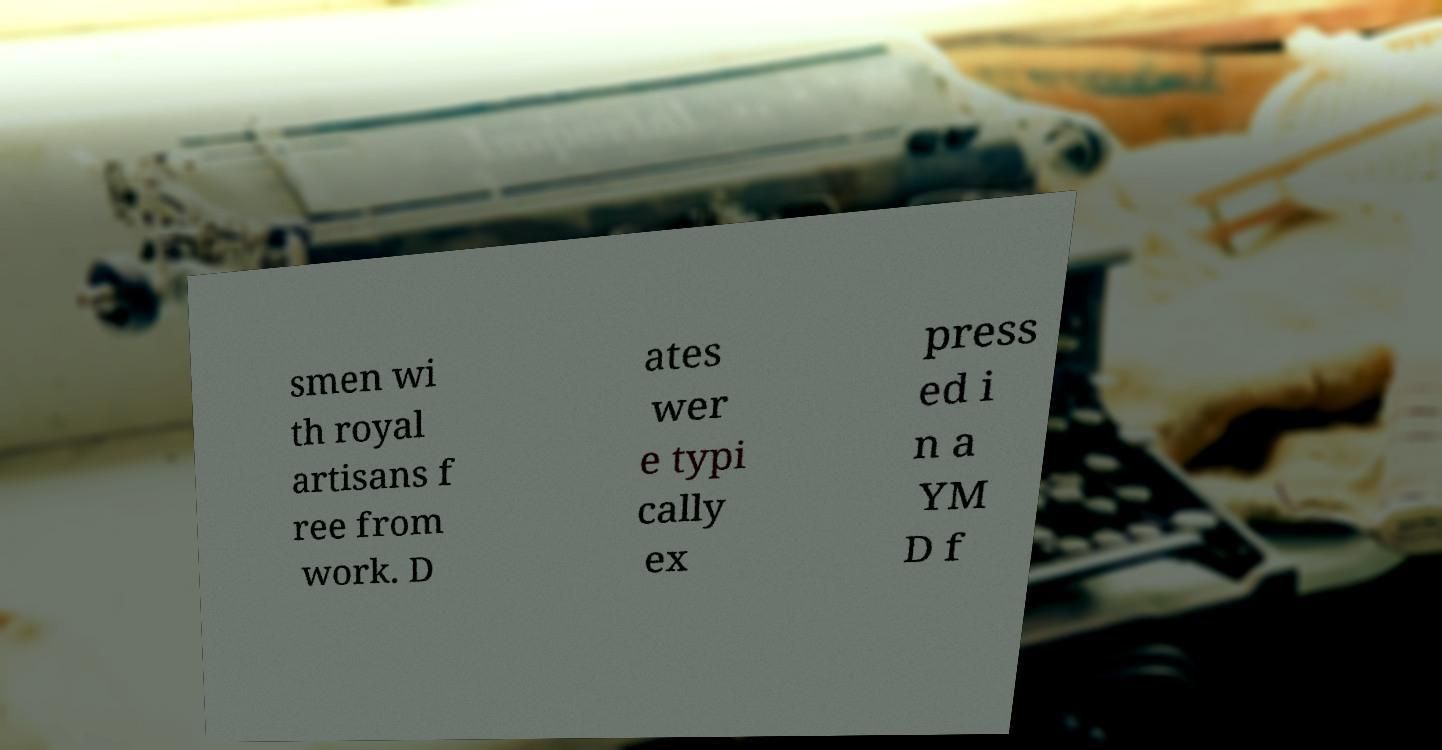Can you read and provide the text displayed in the image?This photo seems to have some interesting text. Can you extract and type it out for me? smen wi th royal artisans f ree from work. D ates wer e typi cally ex press ed i n a YM D f 